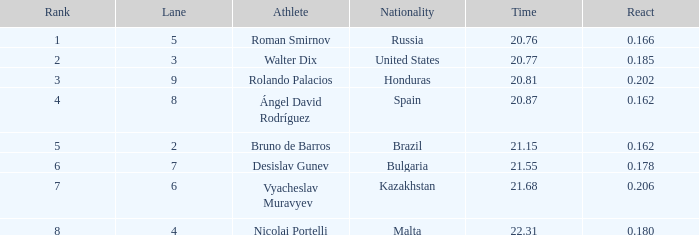Which position did russia hold prior to being ranked number 1? None. 